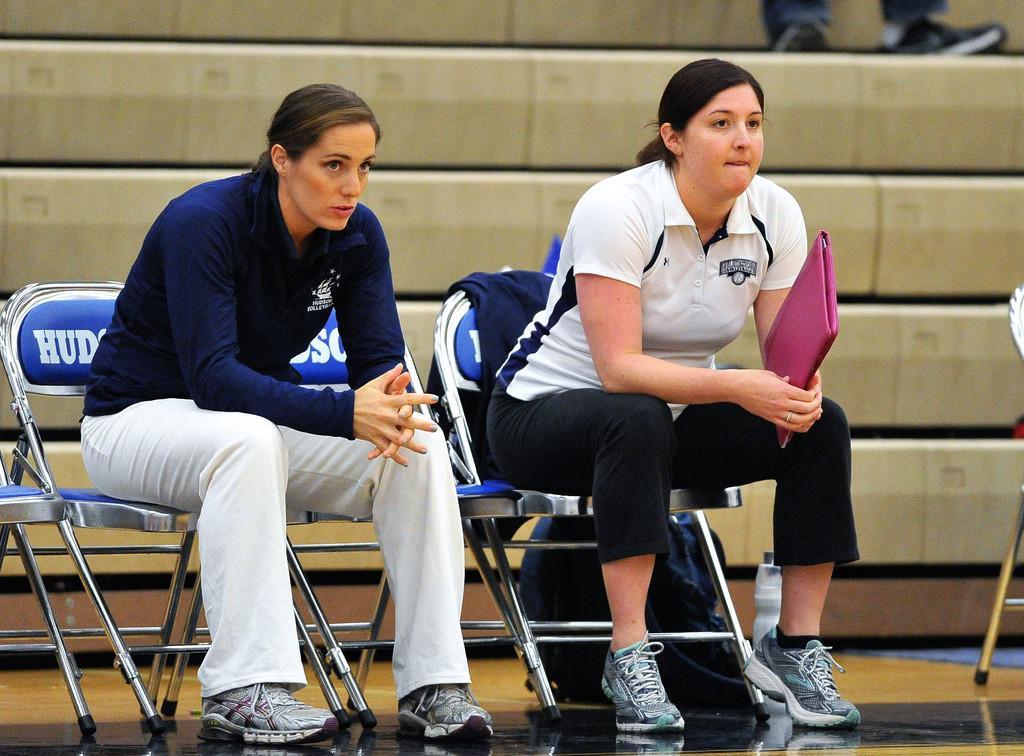Could you give a brief overview of what you see in this image? There are two women sitting on chairs and the women in the right side is holding a file 